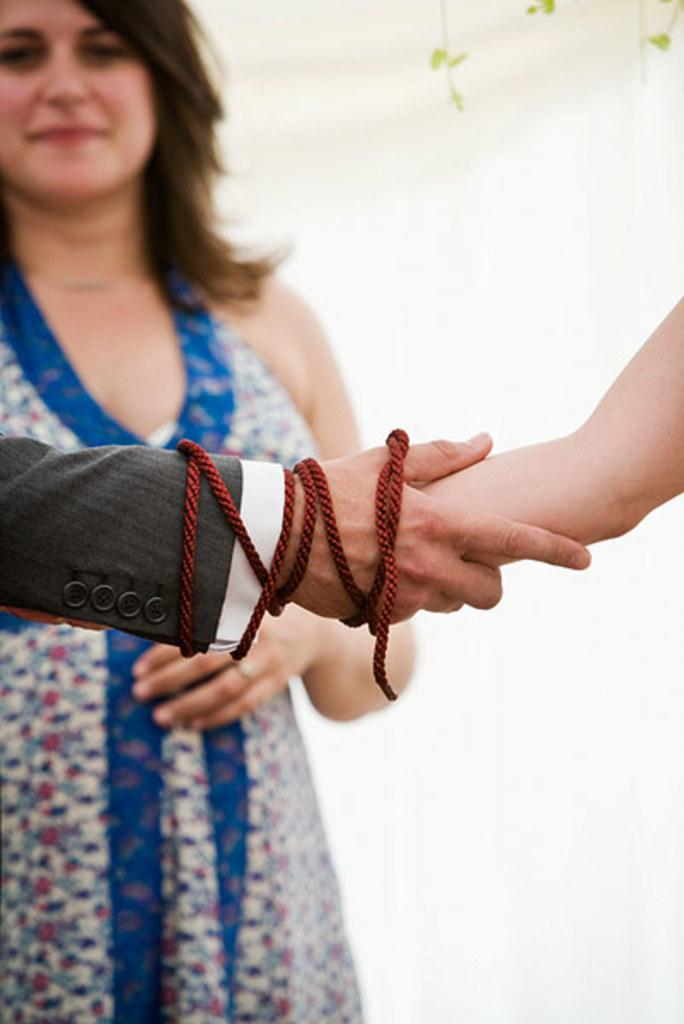What is the main subject of the image? There is a person in the image. What is the person doing with their hands in the image? The person is holding their hands in the foreground. What color is the background of the image? The background of the image is white. What type of store can be seen in the background of the image? There is no store visible in the background of the image; the background is white. 